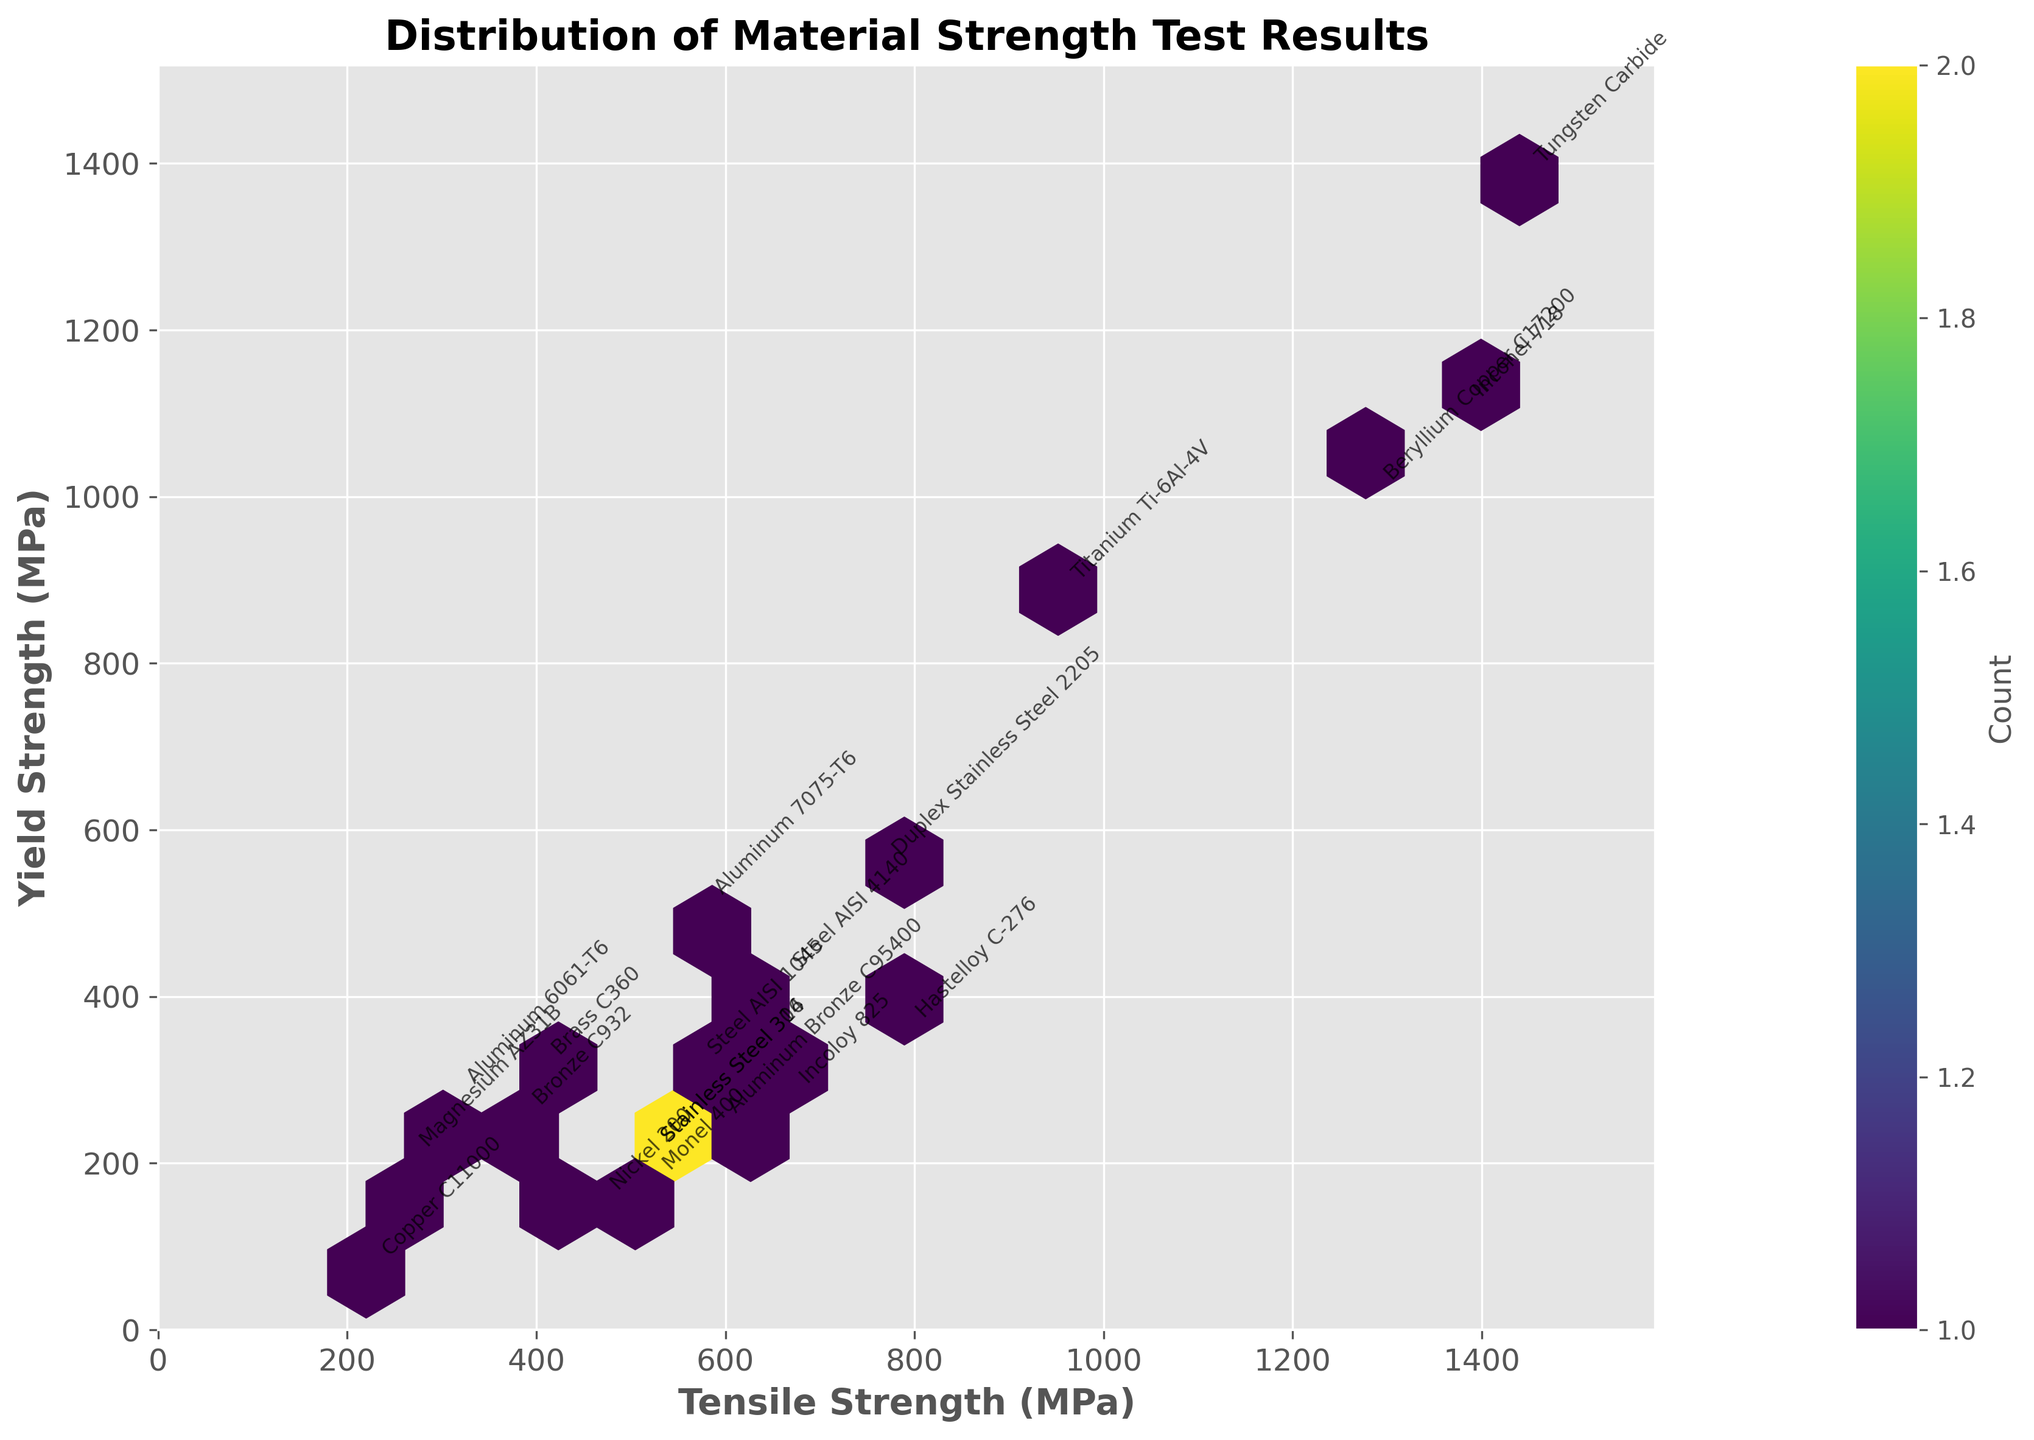What's the title of the Hexbin plot? Look at the top of the figure where the title is usually placed.
Answer: Distribution of Material Strength Test Results What does the color intensity in the hexagons represent? In a hexbin plot, the color intensity typically indicates the count of data points within each hexagon. This is confirmed by the color bar labeled 'Count' on the right.
Answer: Count of data points Which material has the highest tensile strength, and what is that value? Locate the point at the far right on the x-axis and read its annotated label. The tensile strength value is just above that point.
Answer: Tungsten Carbide, 1440 MPa How many different materials are represented in the plot? Count the unique annotations or data points plotted, each representing a different material.
Answer: 20 What is the relationship between tensile strength and yield strength based on the overall distribution in the plot? Observe the general trend of the data points. As the tensile strength increases, the yield strength also increases, indicating a positive correlation.
Answer: Positive correlation Which material has both the lowest tensile and yield strength, and what are these values? Find the point at the lower left of the plot and read its annotated label and values along the axes.
Answer: Copper C11000, Tensile Strength: 220 MPa, Yield Strength: 69 MPa What is the range of yield strength values in this dataset? Find the minimum and maximum values on the y-axis by locating the lowest and highest points. The lowest yield strength is for Copper C11000 (69 MPa) and the highest for Tungsten Carbide (1380 MPa).
Answer: 69 MPa to 1380 MPa How does the tensile strength of Aluminum 7075-T6 compare to that of Steel AISI 1045? Find and compare the annotated points for Aluminum 7075-T6 and Steel AISI 1045 along the x-axis. Aluminum 7075-T6 has a tensile strength of 572 MPa, whereas Steel AISI 1045 has 565 MPa.
Answer: Aluminum 7075-T6: 572 MPa, Steel AISI 1045: 565 MPa Which two materials have the exact same yield strength, and what is that value? Look for overlapping or closely placed annotations along the y-axis and check their yield strength values. Both Stainless Steel 304 and Stainless Steel 316 have a yield strength of 205 MPa.
Answer: Stainless Steel 304 and Stainless Steel 316, 205 MPa Are there any clusters or concentrations of materials in certain strength ranges? Where are they located? Identify any areas with darker hexagons, indicating a higher density of data points. There is a concentration around the mid-range tensile strength (500-700 MPa) and yield strength (200-400 MPa).
Answer: Mid-range tensile strength (500-700 MPa) and yield strength (200-400 MPa) 